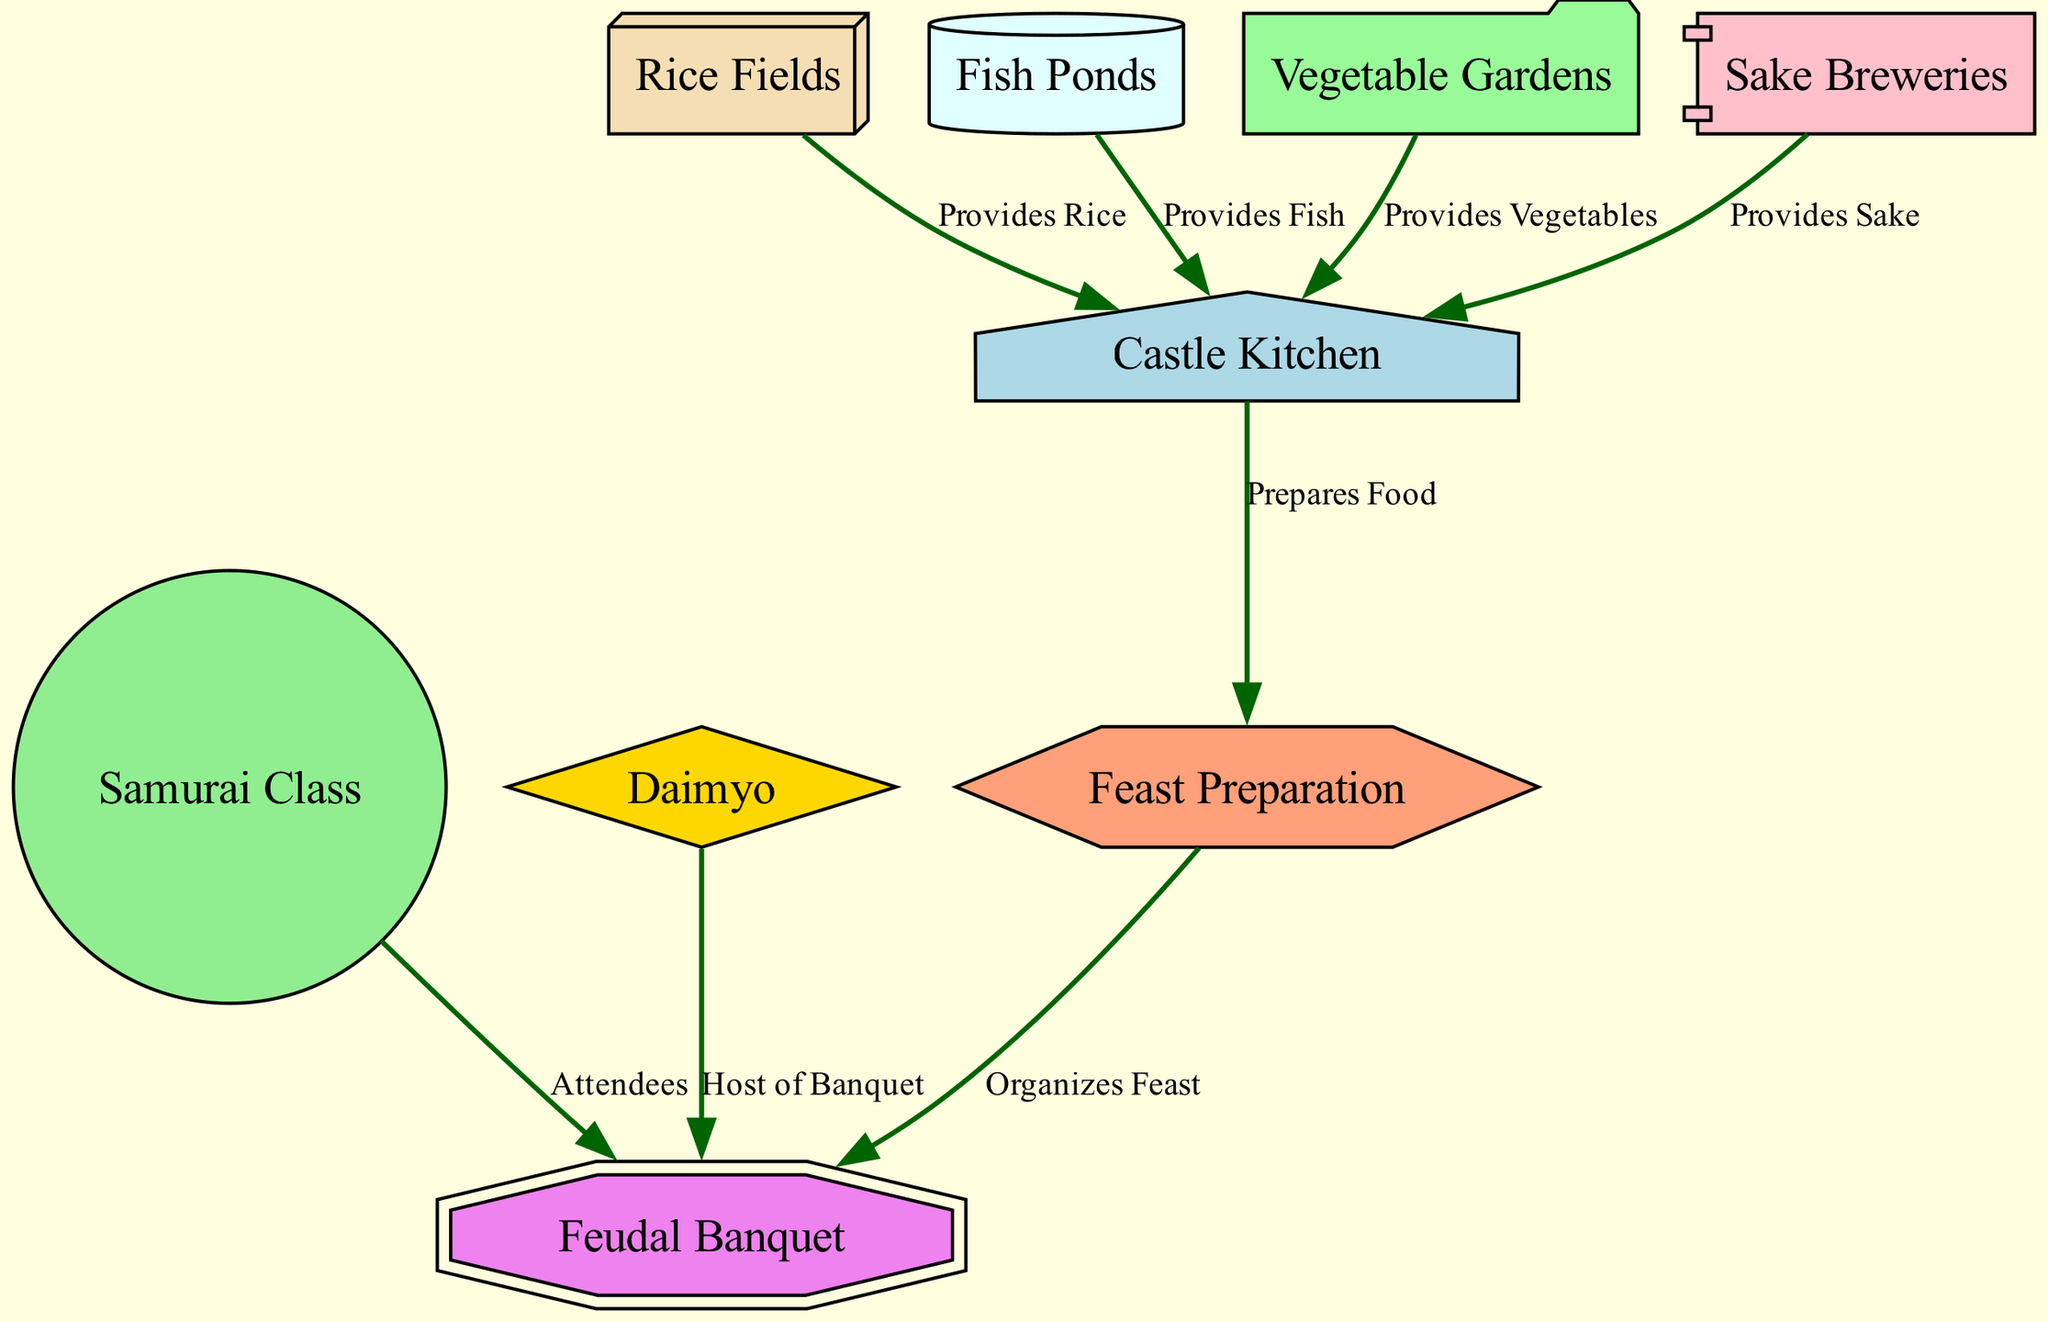What is the host of the Feudal Banquet? The diagram indicates that the "Daimyo" is the host of the "Feudal Banquet" as it is directly connected to the "Feudal Banquet" node with a labeled edge indicating the hosting relationship.
Answer: Daimyo How many nodes are in the diagram? By counting all the unique elements represented as circles in the diagram, there are a total of 9 distinct nodes that contribute to the food chain in feudal Japanese castles.
Answer: 9 What does the Castle Kitchen provide? The diagram shows that the "Castle Kitchen" is the central node that prepares food from various sources, including rice, fish, vegetables, and sake provided by specific nodes linked to it.
Answer: Food Which node provides vegetables? In the diagram, the "Vegetable Gardens" node has a direct connection to the "Castle Kitchen," indicating its role in providing vegetables for preparation and consumption.
Answer: Vegetable Gardens Who are the attendees of the Feudal Banquet? The "Samurai Class" node is directly connected to the "Feudal Banquet" node, which indicates that they are the attendees of the feast organized by the Castle Kitchen and hosted by the Daimyo.
Answer: Samurai Class What node organizes the feast? According to the diagram, the "Feast Preparation" node is responsible for organizing the "Feudal Banquet," as shown by the direct link from "Feast Preparation" to "Feudal Banquet."
Answer: Feast Preparation Which nodes contribute to the food supply of the Castle Kitchen? The diagram shows a flow from four different nodes: "Rice Fields," "Fish Ponds," "Vegetable Gardens," and "Sake Breweries," all providing essential ingredients to the Castle Kitchen for meal preparation.
Answer: Rice Fields, Fish Ponds, Vegetable Gardens, Sake Breweries How many edges are in the diagram? A thorough count of the connections representing relationships and flows among the nodes shows that there are a total of 8 edges in the diagram linking the various aspects of the food chain.
Answer: 8 What role does the Castle Kitchen play in the food chain? The Castle Kitchen serves as a central hub by receiving inputs from various food sources and is responsible for preparing the food which is then used in the feasts organized for the attendees.
Answer: Prepares Food 